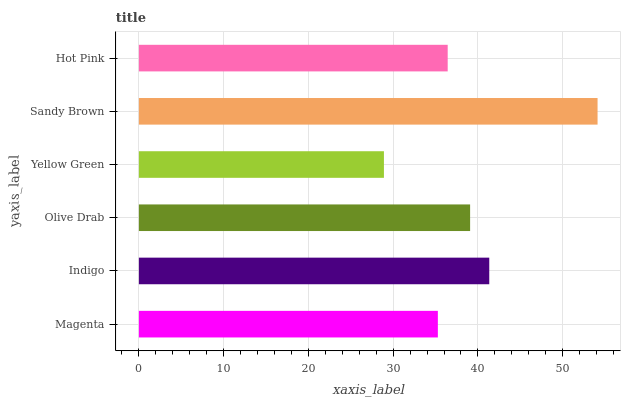Is Yellow Green the minimum?
Answer yes or no. Yes. Is Sandy Brown the maximum?
Answer yes or no. Yes. Is Indigo the minimum?
Answer yes or no. No. Is Indigo the maximum?
Answer yes or no. No. Is Indigo greater than Magenta?
Answer yes or no. Yes. Is Magenta less than Indigo?
Answer yes or no. Yes. Is Magenta greater than Indigo?
Answer yes or no. No. Is Indigo less than Magenta?
Answer yes or no. No. Is Olive Drab the high median?
Answer yes or no. Yes. Is Hot Pink the low median?
Answer yes or no. Yes. Is Yellow Green the high median?
Answer yes or no. No. Is Olive Drab the low median?
Answer yes or no. No. 